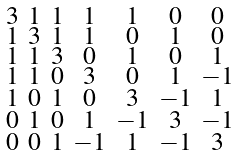<formula> <loc_0><loc_0><loc_500><loc_500>\begin{smallmatrix} 3 & 1 & 1 & 1 & 1 & 0 & 0 \\ 1 & 3 & 1 & 1 & 0 & 1 & 0 \\ 1 & 1 & 3 & 0 & 1 & 0 & 1 \\ 1 & 1 & 0 & 3 & 0 & 1 & - 1 \\ 1 & 0 & 1 & 0 & 3 & - 1 & 1 \\ 0 & 1 & 0 & 1 & - 1 & 3 & - 1 \\ 0 & 0 & 1 & - 1 & 1 & - 1 & 3 \end{smallmatrix}</formula> 